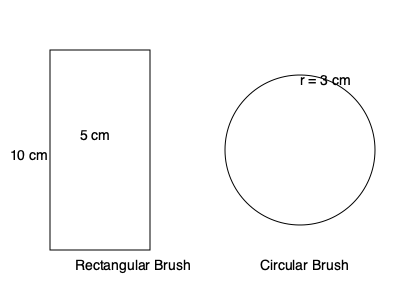You have two makeup brushes: a rectangular brush with dimensions 5 cm by 10 cm, and a circular brush with a radius of 3 cm. If you use both brushes to apply foundation, what is the total surface area that can be covered in one application? Round your answer to the nearest square centimeter. To solve this problem, we need to calculate the surface area of each brush and then add them together:

1. For the rectangular brush:
   Area = length × width
   $A_r = 5 \text{ cm} \times 10 \text{ cm} = 50 \text{ cm}^2$

2. For the circular brush:
   Area = $\pi r^2$
   $A_c = \pi \times (3 \text{ cm})^2 = 9\pi \text{ cm}^2$

3. Calculate the exact total area:
   $A_{\text{total}} = A_r + A_c = 50 \text{ cm}^2 + 9\pi \text{ cm}^2$
   $A_{\text{total}} = 50 + 28.27 = 78.27 \text{ cm}^2$

4. Round to the nearest square centimeter:
   $78.27 \text{ cm}^2 \approx 78 \text{ cm}^2$

Therefore, the total surface area that can be covered in one application is approximately 78 cm².
Answer: 78 cm² 